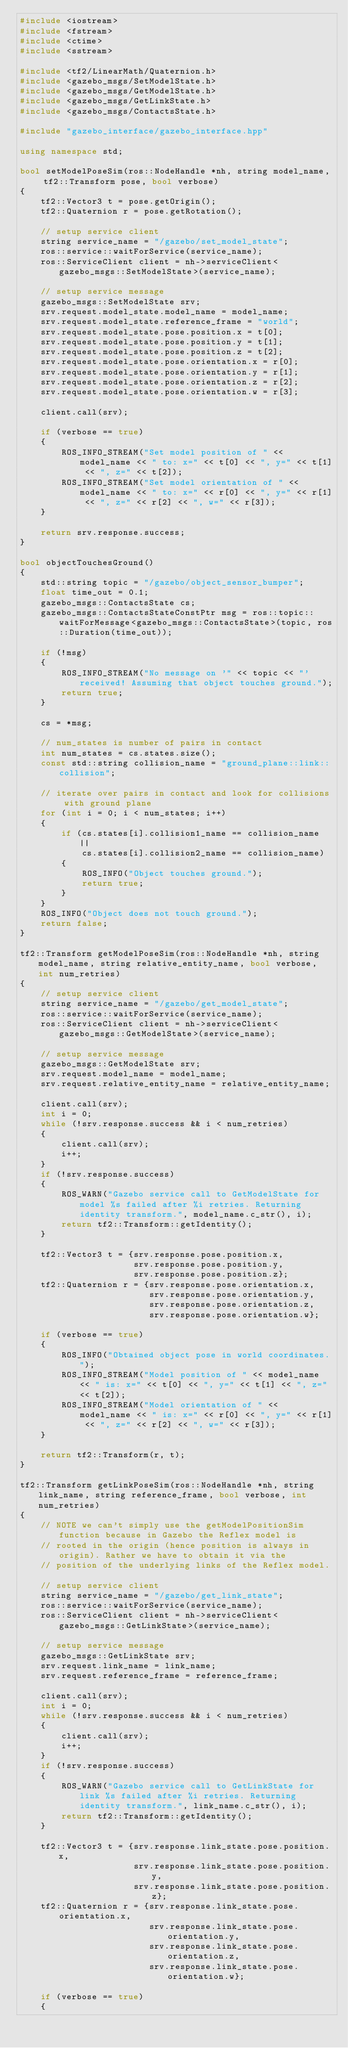Convert code to text. <code><loc_0><loc_0><loc_500><loc_500><_C++_>#include <iostream>
#include <fstream>
#include <ctime>
#include <sstream>

#include <tf2/LinearMath/Quaternion.h>
#include <gazebo_msgs/SetModelState.h>
#include <gazebo_msgs/GetModelState.h>
#include <gazebo_msgs/GetLinkState.h>
#include <gazebo_msgs/ContactsState.h>

#include "gazebo_interface/gazebo_interface.hpp"

using namespace std;

bool setModelPoseSim(ros::NodeHandle *nh, string model_name, tf2::Transform pose, bool verbose)
{
    tf2::Vector3 t = pose.getOrigin();
    tf2::Quaternion r = pose.getRotation();

    // setup service client
    string service_name = "/gazebo/set_model_state";
    ros::service::waitForService(service_name);
    ros::ServiceClient client = nh->serviceClient<gazebo_msgs::SetModelState>(service_name);

    // setup service message
    gazebo_msgs::SetModelState srv;
    srv.request.model_state.model_name = model_name;
    srv.request.model_state.reference_frame = "world";
    srv.request.model_state.pose.position.x = t[0];
    srv.request.model_state.pose.position.y = t[1];
    srv.request.model_state.pose.position.z = t[2];
    srv.request.model_state.pose.orientation.x = r[0];
    srv.request.model_state.pose.orientation.y = r[1];
    srv.request.model_state.pose.orientation.z = r[2];
    srv.request.model_state.pose.orientation.w = r[3];

    client.call(srv);

    if (verbose == true)
    {
        ROS_INFO_STREAM("Set model position of " << model_name << " to: x=" << t[0] << ", y=" << t[1] << ", z=" << t[2]);
        ROS_INFO_STREAM("Set model orientation of " << model_name << " to: x=" << r[0] << ", y=" << r[1] << ", z=" << r[2] << ", w=" << r[3]);
    }

    return srv.response.success;
}

bool objectTouchesGround()
{
    std::string topic = "/gazebo/object_sensor_bumper";
    float time_out = 0.1;
    gazebo_msgs::ContactsState cs;
    gazebo_msgs::ContactsStateConstPtr msg = ros::topic::waitForMessage<gazebo_msgs::ContactsState>(topic, ros::Duration(time_out));

    if (!msg)
    {
        ROS_INFO_STREAM("No message on '" << topic << "' received! Assuming that object touches ground.");
        return true;
    }

    cs = *msg;

    // num_states is number of pairs in contact
    int num_states = cs.states.size();
    const std::string collision_name = "ground_plane::link::collision";

    // iterate over pairs in contact and look for collisions with ground plane
    for (int i = 0; i < num_states; i++)
    {
        if (cs.states[i].collision1_name == collision_name ||
            cs.states[i].collision2_name == collision_name)
        {
            ROS_INFO("Object touches ground.");
            return true;
        }
    }
    ROS_INFO("Object does not touch ground.");
    return false;
}

tf2::Transform getModelPoseSim(ros::NodeHandle *nh, string model_name, string relative_entity_name, bool verbose, int num_retries)
{
    // setup service client
    string service_name = "/gazebo/get_model_state";
    ros::service::waitForService(service_name);
    ros::ServiceClient client = nh->serviceClient<gazebo_msgs::GetModelState>(service_name);

    // setup service message
    gazebo_msgs::GetModelState srv;
    srv.request.model_name = model_name;
    srv.request.relative_entity_name = relative_entity_name;

    client.call(srv);
    int i = 0;
    while (!srv.response.success && i < num_retries)
    {
        client.call(srv);
        i++;
    }
    if (!srv.response.success)
    {
        ROS_WARN("Gazebo service call to GetModelState for model %s failed after %i retries. Returning identity transform.", model_name.c_str(), i);
        return tf2::Transform::getIdentity();
    }

    tf2::Vector3 t = {srv.response.pose.position.x,
                      srv.response.pose.position.y,
                      srv.response.pose.position.z};
    tf2::Quaternion r = {srv.response.pose.orientation.x,
                         srv.response.pose.orientation.y,
                         srv.response.pose.orientation.z,
                         srv.response.pose.orientation.w};

    if (verbose == true)
    {
        ROS_INFO("Obtained object pose in world coordinates.");
        ROS_INFO_STREAM("Model position of " << model_name << " is: x=" << t[0] << ", y=" << t[1] << ", z=" << t[2]);
        ROS_INFO_STREAM("Model orientation of " << model_name << " is: x=" << r[0] << ", y=" << r[1] << ", z=" << r[2] << ", w=" << r[3]);
    }

    return tf2::Transform(r, t);
}

tf2::Transform getLinkPoseSim(ros::NodeHandle *nh, string link_name, string reference_frame, bool verbose, int num_retries)
{
    // NOTE we can't simply use the getModelPositionSim function because in Gazebo the Reflex model is
    // rooted in the origin (hence position is always in origin). Rather we have to obtain it via the
    // position of the underlying links of the Reflex model.

    // setup service client
    string service_name = "/gazebo/get_link_state";
    ros::service::waitForService(service_name);
    ros::ServiceClient client = nh->serviceClient<gazebo_msgs::GetLinkState>(service_name);

    // setup service message
    gazebo_msgs::GetLinkState srv;
    srv.request.link_name = link_name;
    srv.request.reference_frame = reference_frame;

    client.call(srv);
    int i = 0;
    while (!srv.response.success && i < num_retries)
    {
        client.call(srv);
        i++;
    }
    if (!srv.response.success)
    {
        ROS_WARN("Gazebo service call to GetLinkState for link %s failed after %i retries. Returning identity transform.", link_name.c_str(), i);
        return tf2::Transform::getIdentity();
    }

    tf2::Vector3 t = {srv.response.link_state.pose.position.x,
                      srv.response.link_state.pose.position.y,
                      srv.response.link_state.pose.position.z};
    tf2::Quaternion r = {srv.response.link_state.pose.orientation.x,
                         srv.response.link_state.pose.orientation.y,
                         srv.response.link_state.pose.orientation.z,
                         srv.response.link_state.pose.orientation.w};

    if (verbose == true)
    {</code> 